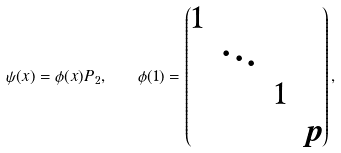Convert formula to latex. <formula><loc_0><loc_0><loc_500><loc_500>\psi ( x ) = \phi ( x ) P _ { 2 } , \quad \phi ( 1 ) = \begin{pmatrix} 1 \\ & \ddots \\ & & 1 \\ & & & p \end{pmatrix} ,</formula> 